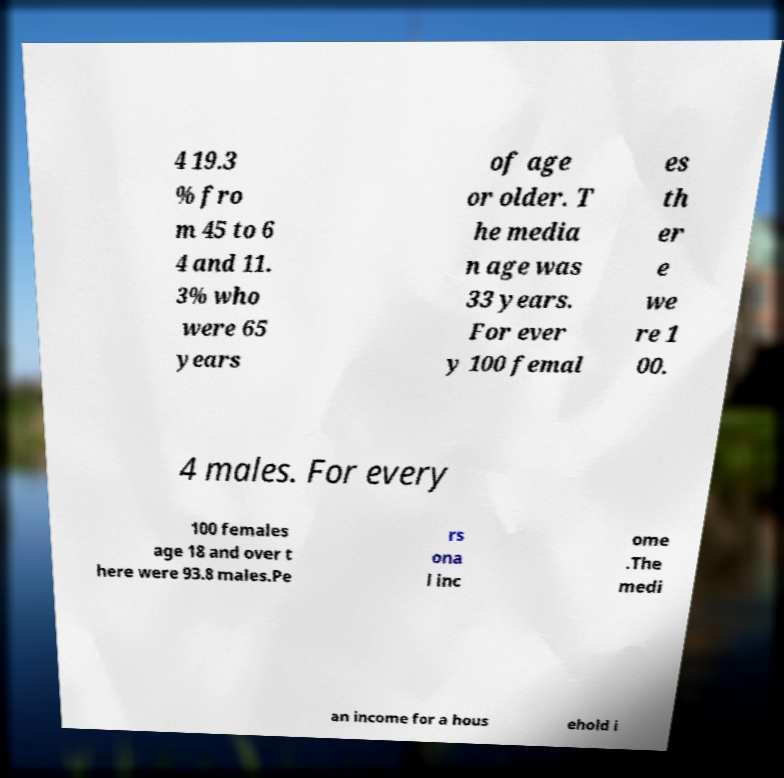There's text embedded in this image that I need extracted. Can you transcribe it verbatim? 4 19.3 % fro m 45 to 6 4 and 11. 3% who were 65 years of age or older. T he media n age was 33 years. For ever y 100 femal es th er e we re 1 00. 4 males. For every 100 females age 18 and over t here were 93.8 males.Pe rs ona l inc ome .The medi an income for a hous ehold i 